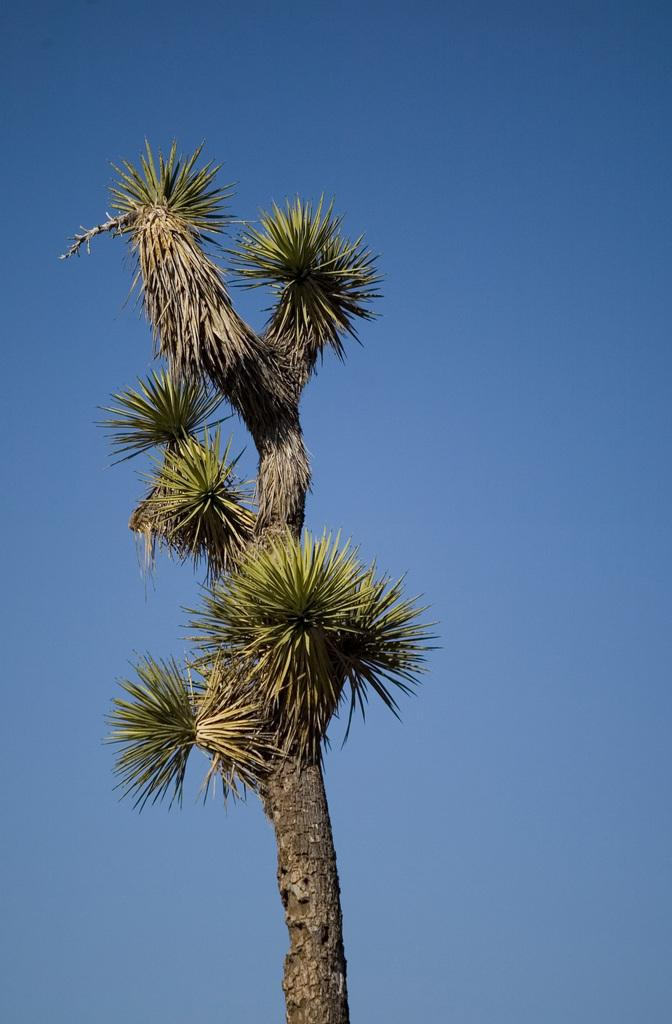What is the main subject in the center of the image? There is a tree in the center of the image. What can be seen in the background of the image? There is a sky visible in the background of the image. How does the tree increase in size in the image? The tree does not increase in size in the image; it is a static representation of a tree. 